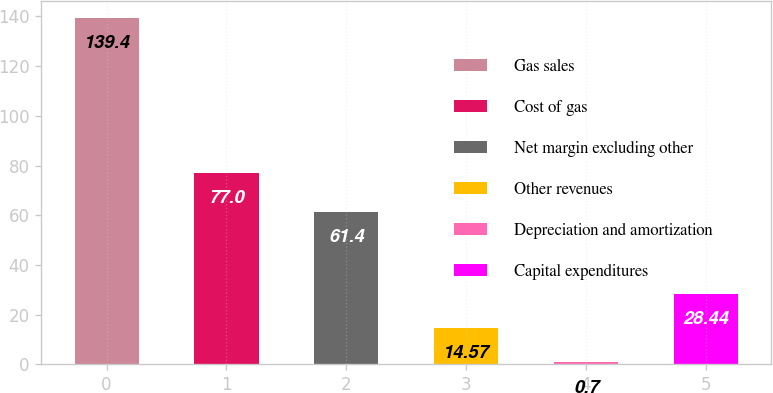<chart> <loc_0><loc_0><loc_500><loc_500><bar_chart><fcel>Gas sales<fcel>Cost of gas<fcel>Net margin excluding other<fcel>Other revenues<fcel>Depreciation and amortization<fcel>Capital expenditures<nl><fcel>139.4<fcel>77<fcel>61.4<fcel>14.57<fcel>0.7<fcel>28.44<nl></chart> 